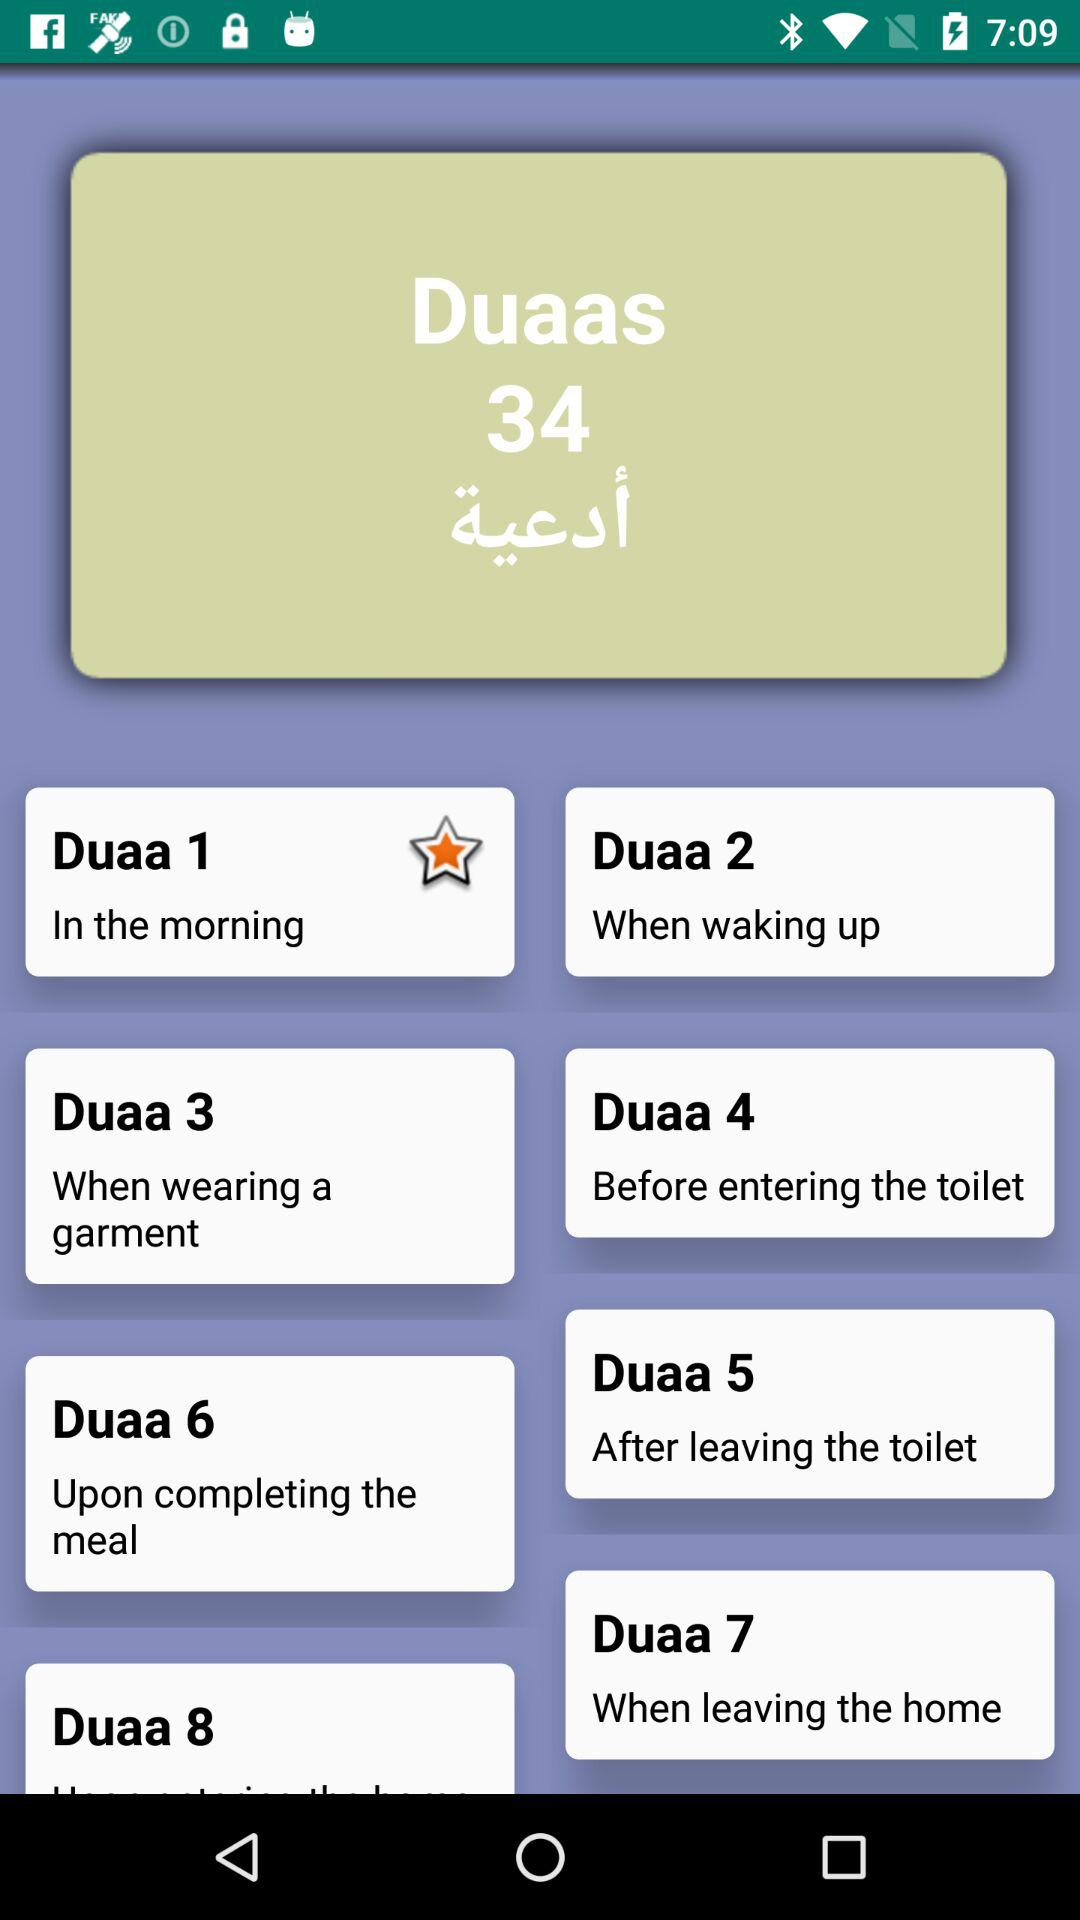When should "Duaa 7" be performed? "Duaa 7" should be performed when leaving the home. 